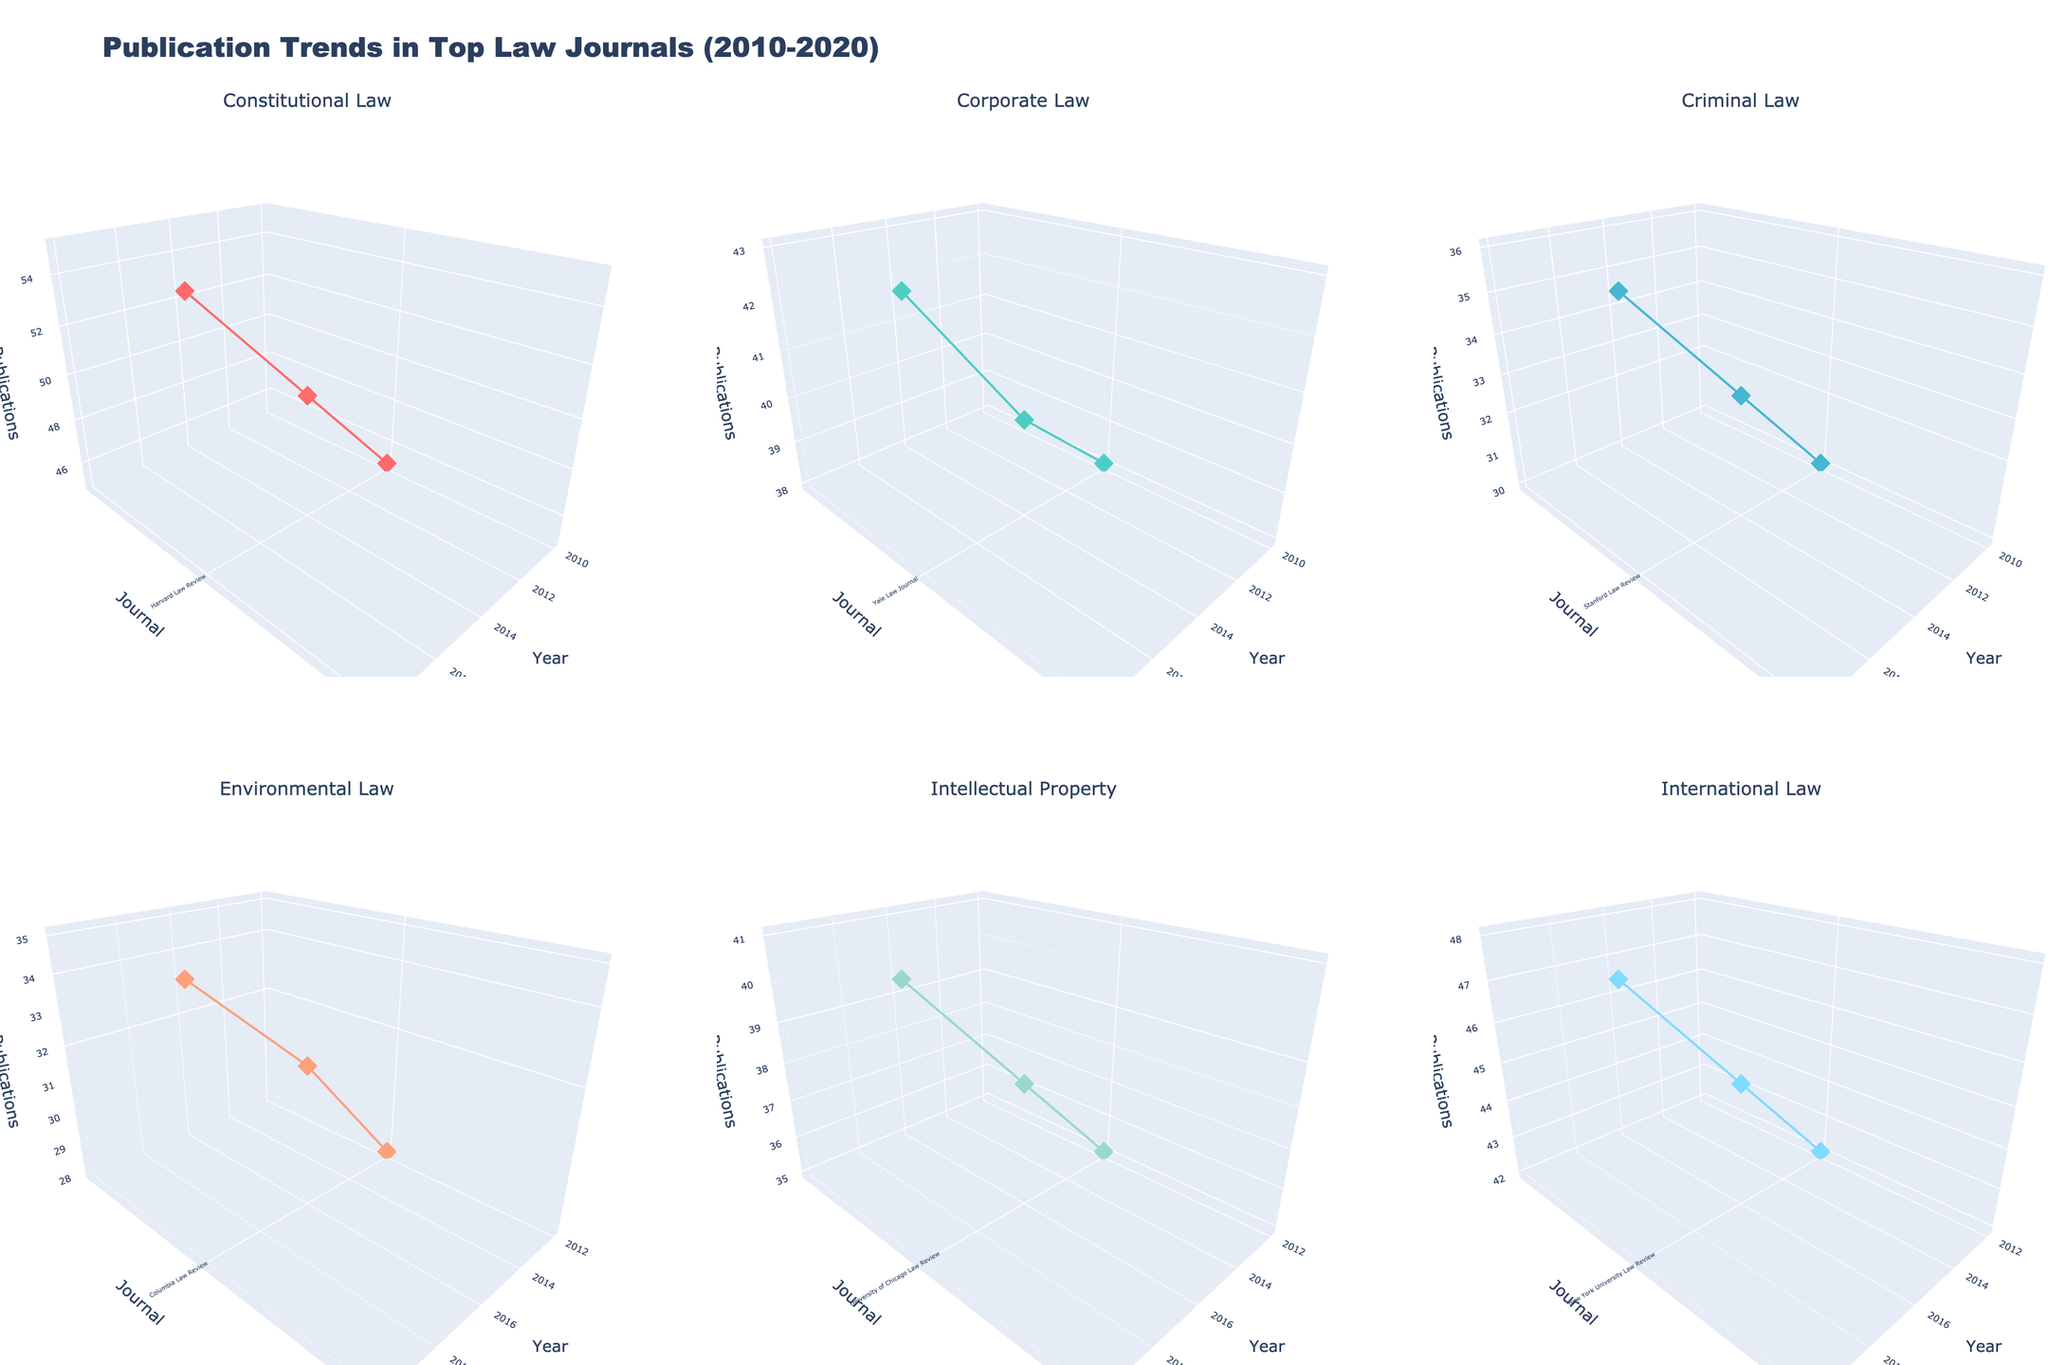What's the title of the figure? The title can be found at the top of the figure, indicating the central focus of the plots.
Answer: Publication Trends in Top Law Journals (2010-2020) How many subplots are there in total? Count the individual 3D plots within the main plot.
Answer: 6 Which specialization has the highest publication count in 2020? Check the 'z' axis for 2020 in each 3D subplot and identify the highest point.
Answer: International Law What journal consistently has the highest publication count in Constitutional Law over the years? Focus on the subplot for Constitutional Law and follow the 'z' axis for each year to identify which journal consistently stays highest.
Answer: Harvard Law Review In 2012, which specialization had the least number of publications across all journals? Check each specialization's 2012 data points and compare the publication counts on the 'z' axis.
Answer: Environmental Law Compare the publication counts in Yale Law Journal for Corporate Law in 2010 and 2014. What is the difference? Locate the points for Yale Law Journal in Corporate Law for 2010 and 2014 in the respective subplot, then subtract the 2010 count from the 2014 count.
Answer: 2 What's the average number of publications in Columbia Law Review for Environmental Law over the years? Sum the number of publications for the respective years (28 + 32 + 35) and divide by the number of years (3).
Answer: 31.67 Is there an upward or downward trend in publications for Stanford Law Review in Criminal Law from 2010 to 2020? Observe the 'z' axis points for the specific journal from 2010, 2014, and 2018 to identify the trend.
Answer: Upward Which specialization has the most uniform distribution of publications over the years across all journals? Visualize the 3D plots for each specialization and find the one with the least variation in 'z' axis values.
Answer: Corporate Law How many journals have publication counts exceeding 40 in 2018 for Corporate Law? In the Corporate Law subplot, count the number of data points above 40 on the 'z' axis for the year 2018.
Answer: 1 